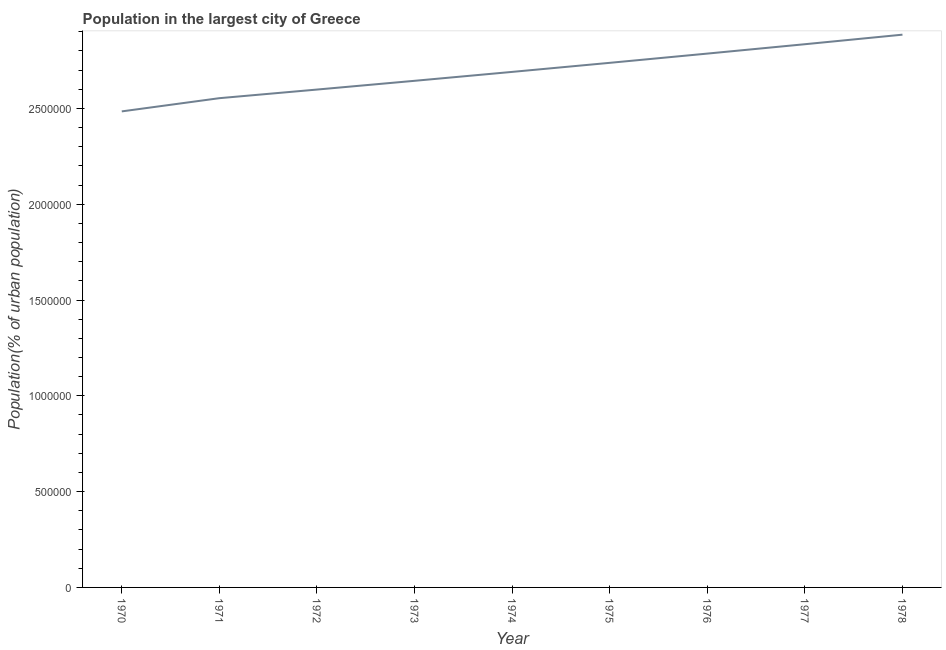What is the population in largest city in 1976?
Provide a short and direct response. 2.79e+06. Across all years, what is the maximum population in largest city?
Ensure brevity in your answer.  2.89e+06. Across all years, what is the minimum population in largest city?
Provide a short and direct response. 2.48e+06. In which year was the population in largest city maximum?
Your answer should be compact. 1978. In which year was the population in largest city minimum?
Give a very brief answer. 1970. What is the sum of the population in largest city?
Offer a very short reply. 2.42e+07. What is the difference between the population in largest city in 1973 and 1977?
Your response must be concise. -1.91e+05. What is the average population in largest city per year?
Provide a succinct answer. 2.69e+06. What is the median population in largest city?
Give a very brief answer. 2.69e+06. What is the ratio of the population in largest city in 1975 to that in 1976?
Provide a short and direct response. 0.98. Is the population in largest city in 1970 less than that in 1972?
Ensure brevity in your answer.  Yes. What is the difference between the highest and the second highest population in largest city?
Offer a very short reply. 4.99e+04. What is the difference between the highest and the lowest population in largest city?
Keep it short and to the point. 4.00e+05. Does the graph contain grids?
Provide a succinct answer. No. What is the title of the graph?
Offer a terse response. Population in the largest city of Greece. What is the label or title of the X-axis?
Your response must be concise. Year. What is the label or title of the Y-axis?
Offer a very short reply. Population(% of urban population). What is the Population(% of urban population) of 1970?
Your answer should be very brief. 2.48e+06. What is the Population(% of urban population) of 1971?
Ensure brevity in your answer.  2.55e+06. What is the Population(% of urban population) of 1972?
Give a very brief answer. 2.60e+06. What is the Population(% of urban population) in 1973?
Your answer should be very brief. 2.64e+06. What is the Population(% of urban population) of 1974?
Ensure brevity in your answer.  2.69e+06. What is the Population(% of urban population) in 1975?
Give a very brief answer. 2.74e+06. What is the Population(% of urban population) in 1976?
Give a very brief answer. 2.79e+06. What is the Population(% of urban population) in 1977?
Ensure brevity in your answer.  2.84e+06. What is the Population(% of urban population) in 1978?
Your response must be concise. 2.89e+06. What is the difference between the Population(% of urban population) in 1970 and 1971?
Provide a short and direct response. -6.90e+04. What is the difference between the Population(% of urban population) in 1970 and 1972?
Make the answer very short. -1.14e+05. What is the difference between the Population(% of urban population) in 1970 and 1973?
Make the answer very short. -1.60e+05. What is the difference between the Population(% of urban population) in 1970 and 1974?
Offer a very short reply. -2.06e+05. What is the difference between the Population(% of urban population) in 1970 and 1975?
Ensure brevity in your answer.  -2.53e+05. What is the difference between the Population(% of urban population) in 1970 and 1976?
Your answer should be compact. -3.02e+05. What is the difference between the Population(% of urban population) in 1970 and 1977?
Offer a terse response. -3.51e+05. What is the difference between the Population(% of urban population) in 1970 and 1978?
Make the answer very short. -4.00e+05. What is the difference between the Population(% of urban population) in 1971 and 1972?
Your answer should be compact. -4.50e+04. What is the difference between the Population(% of urban population) in 1971 and 1973?
Your answer should be compact. -9.06e+04. What is the difference between the Population(% of urban population) in 1971 and 1974?
Your answer should be compact. -1.37e+05. What is the difference between the Population(% of urban population) in 1971 and 1975?
Your answer should be very brief. -1.84e+05. What is the difference between the Population(% of urban population) in 1971 and 1976?
Provide a short and direct response. -2.33e+05. What is the difference between the Population(% of urban population) in 1971 and 1977?
Keep it short and to the point. -2.82e+05. What is the difference between the Population(% of urban population) in 1971 and 1978?
Give a very brief answer. -3.32e+05. What is the difference between the Population(% of urban population) in 1972 and 1973?
Provide a succinct answer. -4.56e+04. What is the difference between the Population(% of urban population) in 1972 and 1974?
Your response must be concise. -9.22e+04. What is the difference between the Population(% of urban population) in 1972 and 1975?
Offer a very short reply. -1.39e+05. What is the difference between the Population(% of urban population) in 1972 and 1976?
Make the answer very short. -1.88e+05. What is the difference between the Population(% of urban population) in 1972 and 1977?
Provide a short and direct response. -2.37e+05. What is the difference between the Population(% of urban population) in 1972 and 1978?
Provide a short and direct response. -2.87e+05. What is the difference between the Population(% of urban population) in 1973 and 1974?
Keep it short and to the point. -4.65e+04. What is the difference between the Population(% of urban population) in 1973 and 1975?
Your answer should be compact. -9.38e+04. What is the difference between the Population(% of urban population) in 1973 and 1976?
Your response must be concise. -1.42e+05. What is the difference between the Population(% of urban population) in 1973 and 1977?
Give a very brief answer. -1.91e+05. What is the difference between the Population(% of urban population) in 1973 and 1978?
Offer a terse response. -2.41e+05. What is the difference between the Population(% of urban population) in 1974 and 1975?
Provide a succinct answer. -4.73e+04. What is the difference between the Population(% of urban population) in 1974 and 1976?
Your answer should be very brief. -9.56e+04. What is the difference between the Population(% of urban population) in 1974 and 1977?
Ensure brevity in your answer.  -1.44e+05. What is the difference between the Population(% of urban population) in 1974 and 1978?
Your answer should be very brief. -1.94e+05. What is the difference between the Population(% of urban population) in 1975 and 1976?
Ensure brevity in your answer.  -4.82e+04. What is the difference between the Population(% of urban population) in 1975 and 1977?
Make the answer very short. -9.72e+04. What is the difference between the Population(% of urban population) in 1975 and 1978?
Your answer should be very brief. -1.47e+05. What is the difference between the Population(% of urban population) in 1976 and 1977?
Your response must be concise. -4.89e+04. What is the difference between the Population(% of urban population) in 1976 and 1978?
Give a very brief answer. -9.88e+04. What is the difference between the Population(% of urban population) in 1977 and 1978?
Offer a terse response. -4.99e+04. What is the ratio of the Population(% of urban population) in 1970 to that in 1972?
Make the answer very short. 0.96. What is the ratio of the Population(% of urban population) in 1970 to that in 1974?
Ensure brevity in your answer.  0.92. What is the ratio of the Population(% of urban population) in 1970 to that in 1975?
Provide a succinct answer. 0.91. What is the ratio of the Population(% of urban population) in 1970 to that in 1976?
Provide a short and direct response. 0.89. What is the ratio of the Population(% of urban population) in 1970 to that in 1977?
Provide a succinct answer. 0.88. What is the ratio of the Population(% of urban population) in 1970 to that in 1978?
Ensure brevity in your answer.  0.86. What is the ratio of the Population(% of urban population) in 1971 to that in 1972?
Provide a short and direct response. 0.98. What is the ratio of the Population(% of urban population) in 1971 to that in 1973?
Your response must be concise. 0.97. What is the ratio of the Population(% of urban population) in 1971 to that in 1974?
Make the answer very short. 0.95. What is the ratio of the Population(% of urban population) in 1971 to that in 1975?
Provide a succinct answer. 0.93. What is the ratio of the Population(% of urban population) in 1971 to that in 1976?
Provide a succinct answer. 0.92. What is the ratio of the Population(% of urban population) in 1971 to that in 1977?
Your response must be concise. 0.9. What is the ratio of the Population(% of urban population) in 1971 to that in 1978?
Provide a succinct answer. 0.89. What is the ratio of the Population(% of urban population) in 1972 to that in 1974?
Give a very brief answer. 0.97. What is the ratio of the Population(% of urban population) in 1972 to that in 1975?
Make the answer very short. 0.95. What is the ratio of the Population(% of urban population) in 1972 to that in 1976?
Your response must be concise. 0.93. What is the ratio of the Population(% of urban population) in 1972 to that in 1977?
Your response must be concise. 0.92. What is the ratio of the Population(% of urban population) in 1972 to that in 1978?
Provide a short and direct response. 0.9. What is the ratio of the Population(% of urban population) in 1973 to that in 1975?
Provide a short and direct response. 0.97. What is the ratio of the Population(% of urban population) in 1973 to that in 1976?
Your answer should be very brief. 0.95. What is the ratio of the Population(% of urban population) in 1973 to that in 1977?
Make the answer very short. 0.93. What is the ratio of the Population(% of urban population) in 1973 to that in 1978?
Provide a short and direct response. 0.92. What is the ratio of the Population(% of urban population) in 1974 to that in 1977?
Your response must be concise. 0.95. What is the ratio of the Population(% of urban population) in 1974 to that in 1978?
Offer a very short reply. 0.93. What is the ratio of the Population(% of urban population) in 1975 to that in 1976?
Provide a short and direct response. 0.98. What is the ratio of the Population(% of urban population) in 1975 to that in 1977?
Your answer should be very brief. 0.97. What is the ratio of the Population(% of urban population) in 1975 to that in 1978?
Your response must be concise. 0.95. 